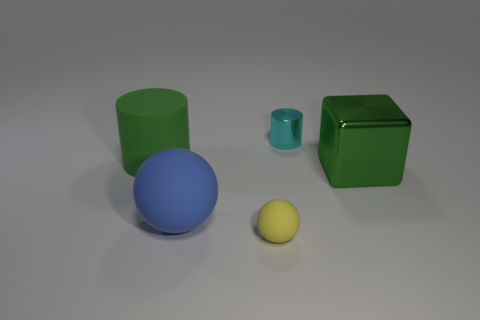What number of things are in front of the rubber cylinder? Three objects are positioned in front of the rubber cylinder: a blue sphere, a small yellow sphere, and a green cube. 